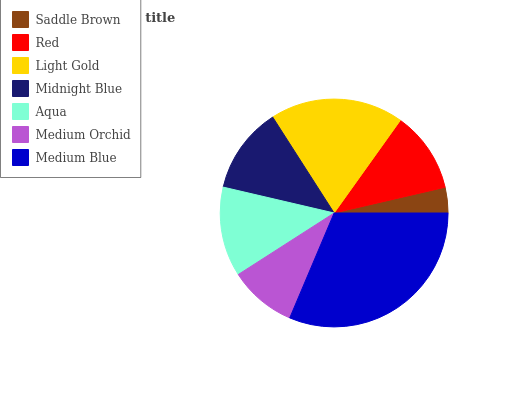Is Saddle Brown the minimum?
Answer yes or no. Yes. Is Medium Blue the maximum?
Answer yes or no. Yes. Is Red the minimum?
Answer yes or no. No. Is Red the maximum?
Answer yes or no. No. Is Red greater than Saddle Brown?
Answer yes or no. Yes. Is Saddle Brown less than Red?
Answer yes or no. Yes. Is Saddle Brown greater than Red?
Answer yes or no. No. Is Red less than Saddle Brown?
Answer yes or no. No. Is Midnight Blue the high median?
Answer yes or no. Yes. Is Midnight Blue the low median?
Answer yes or no. Yes. Is Red the high median?
Answer yes or no. No. Is Medium Orchid the low median?
Answer yes or no. No. 